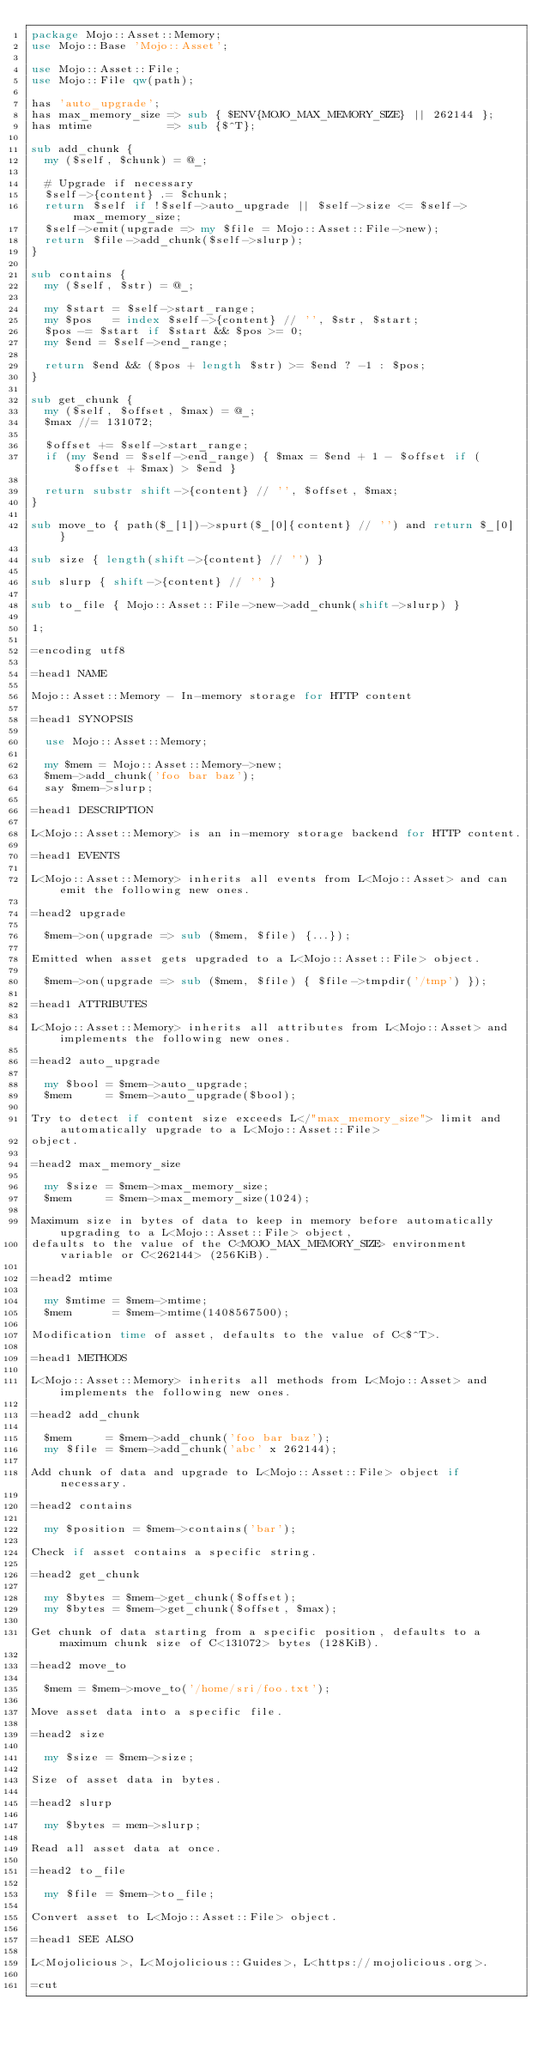Convert code to text. <code><loc_0><loc_0><loc_500><loc_500><_Perl_>package Mojo::Asset::Memory;
use Mojo::Base 'Mojo::Asset';

use Mojo::Asset::File;
use Mojo::File qw(path);

has 'auto_upgrade';
has max_memory_size => sub { $ENV{MOJO_MAX_MEMORY_SIZE} || 262144 };
has mtime           => sub {$^T};

sub add_chunk {
  my ($self, $chunk) = @_;

  # Upgrade if necessary
  $self->{content} .= $chunk;
  return $self if !$self->auto_upgrade || $self->size <= $self->max_memory_size;
  $self->emit(upgrade => my $file = Mojo::Asset::File->new);
  return $file->add_chunk($self->slurp);
}

sub contains {
  my ($self, $str) = @_;

  my $start = $self->start_range;
  my $pos   = index $self->{content} // '', $str, $start;
  $pos -= $start if $start && $pos >= 0;
  my $end = $self->end_range;

  return $end && ($pos + length $str) >= $end ? -1 : $pos;
}

sub get_chunk {
  my ($self, $offset, $max) = @_;
  $max //= 131072;

  $offset += $self->start_range;
  if (my $end = $self->end_range) { $max = $end + 1 - $offset if ($offset + $max) > $end }

  return substr shift->{content} // '', $offset, $max;
}

sub move_to { path($_[1])->spurt($_[0]{content} // '') and return $_[0] }

sub size { length(shift->{content} // '') }

sub slurp { shift->{content} // '' }

sub to_file { Mojo::Asset::File->new->add_chunk(shift->slurp) }

1;

=encoding utf8

=head1 NAME

Mojo::Asset::Memory - In-memory storage for HTTP content

=head1 SYNOPSIS

  use Mojo::Asset::Memory;

  my $mem = Mojo::Asset::Memory->new;
  $mem->add_chunk('foo bar baz');
  say $mem->slurp;

=head1 DESCRIPTION

L<Mojo::Asset::Memory> is an in-memory storage backend for HTTP content.

=head1 EVENTS

L<Mojo::Asset::Memory> inherits all events from L<Mojo::Asset> and can emit the following new ones.

=head2 upgrade

  $mem->on(upgrade => sub ($mem, $file) {...});

Emitted when asset gets upgraded to a L<Mojo::Asset::File> object.

  $mem->on(upgrade => sub ($mem, $file) { $file->tmpdir('/tmp') });

=head1 ATTRIBUTES

L<Mojo::Asset::Memory> inherits all attributes from L<Mojo::Asset> and implements the following new ones.

=head2 auto_upgrade

  my $bool = $mem->auto_upgrade;
  $mem     = $mem->auto_upgrade($bool);

Try to detect if content size exceeds L</"max_memory_size"> limit and automatically upgrade to a L<Mojo::Asset::File>
object.

=head2 max_memory_size

  my $size = $mem->max_memory_size;
  $mem     = $mem->max_memory_size(1024);

Maximum size in bytes of data to keep in memory before automatically upgrading to a L<Mojo::Asset::File> object,
defaults to the value of the C<MOJO_MAX_MEMORY_SIZE> environment variable or C<262144> (256KiB).

=head2 mtime

  my $mtime = $mem->mtime;
  $mem      = $mem->mtime(1408567500);

Modification time of asset, defaults to the value of C<$^T>.

=head1 METHODS

L<Mojo::Asset::Memory> inherits all methods from L<Mojo::Asset> and implements the following new ones.

=head2 add_chunk

  $mem     = $mem->add_chunk('foo bar baz');
  my $file = $mem->add_chunk('abc' x 262144);

Add chunk of data and upgrade to L<Mojo::Asset::File> object if necessary.

=head2 contains

  my $position = $mem->contains('bar');

Check if asset contains a specific string.

=head2 get_chunk

  my $bytes = $mem->get_chunk($offset);
  my $bytes = $mem->get_chunk($offset, $max);

Get chunk of data starting from a specific position, defaults to a maximum chunk size of C<131072> bytes (128KiB).

=head2 move_to

  $mem = $mem->move_to('/home/sri/foo.txt');

Move asset data into a specific file.

=head2 size

  my $size = $mem->size;

Size of asset data in bytes.

=head2 slurp

  my $bytes = mem->slurp;

Read all asset data at once.

=head2 to_file

  my $file = $mem->to_file;

Convert asset to L<Mojo::Asset::File> object.

=head1 SEE ALSO

L<Mojolicious>, L<Mojolicious::Guides>, L<https://mojolicious.org>.

=cut
</code> 